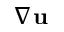<formula> <loc_0><loc_0><loc_500><loc_500>\nabla u</formula> 